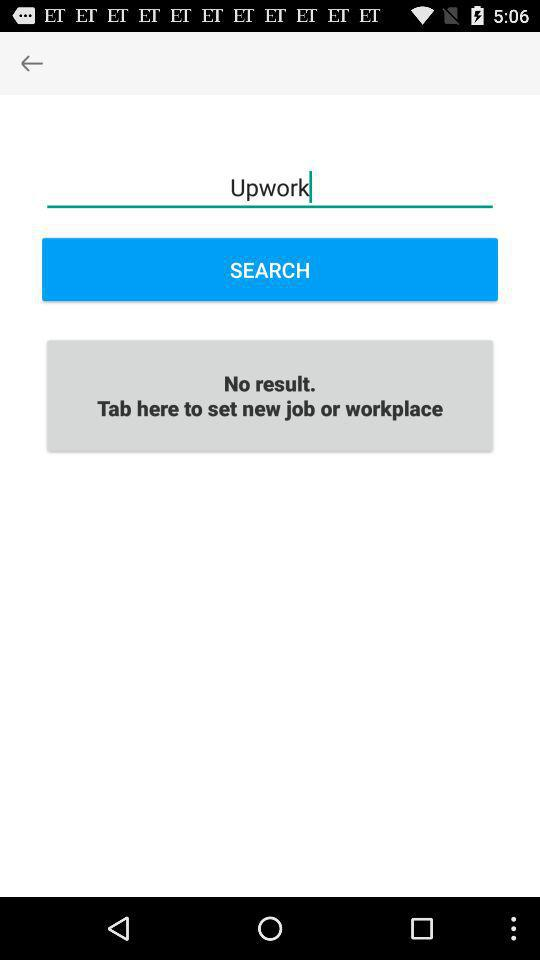What is written in the search bar? In the search bar, "Upwork" is written. 